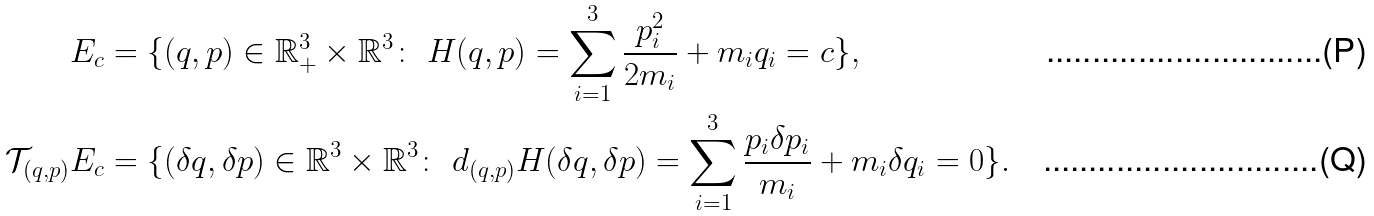<formula> <loc_0><loc_0><loc_500><loc_500>E _ { c } & = \{ ( q , p ) \in \mathbb { R } _ { + } ^ { 3 } \times \mathbb { R } ^ { 3 } \colon \ H ( q , p ) = \sum _ { i = 1 } ^ { 3 } \frac { p _ { i } ^ { 2 } } { 2 m _ { i } } + m _ { i } q _ { i } = c \} , \\ \mathcal { T } _ { ( q , p ) } E _ { c } & = \{ ( \delta q , \delta p ) \in \mathbb { R } ^ { 3 } \times \mathbb { R } ^ { 3 } \colon \ d _ { ( q , p ) } H ( \delta q , \delta p ) = \sum _ { i = 1 } ^ { 3 } \frac { p _ { i } \delta p _ { i } } { m _ { i } } + m _ { i } \delta q _ { i } = 0 \} .</formula> 